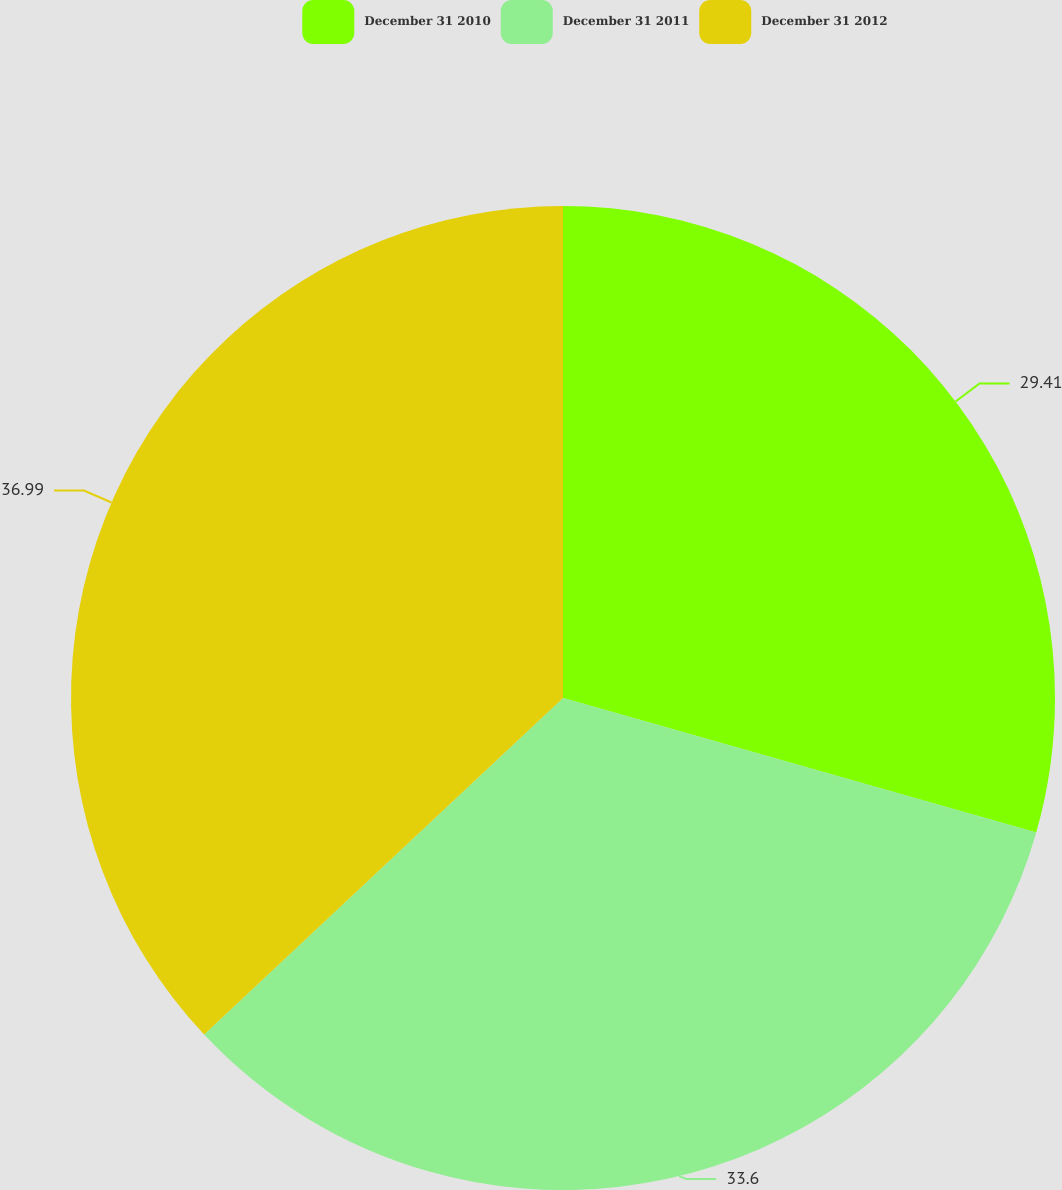Convert chart. <chart><loc_0><loc_0><loc_500><loc_500><pie_chart><fcel>December 31 2010<fcel>December 31 2011<fcel>December 31 2012<nl><fcel>29.41%<fcel>33.6%<fcel>36.99%<nl></chart> 